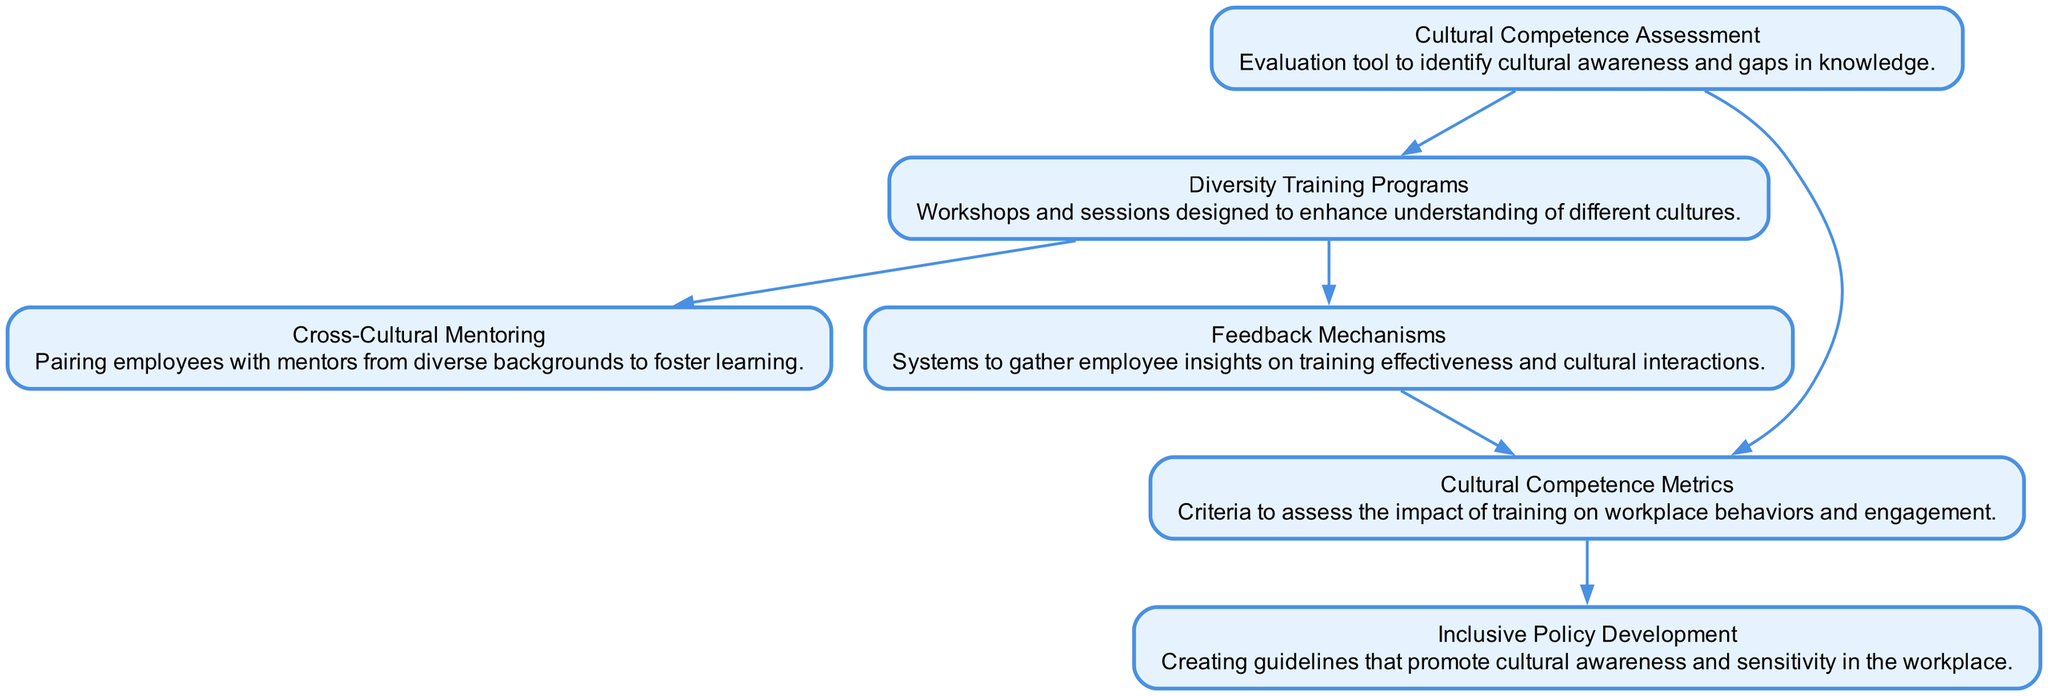What is the first node in the directed graph? The directed graph starts with the node labeled "Cultural Competence Assessment." This is identified as the initial point in the flow of the diagram, as it does not have any incoming edges.
Answer: Cultural Competence Assessment How many nodes are present in the diagram? By counting each unique element listed under "elements," we find a total of six nodes: Cultural Competence Assessment, Diversity Training Programs, Cross-Cultural Mentoring, Feedback Mechanisms, Cultural Competence Metrics, and Inclusive Policy Development.
Answer: Six Which node is directly connected to "Training Programs"? The "Mentoring" and "Feedback Mechanisms" nodes are both directly connected to the "Training Programs" node. This means both nodes receive output from "Training Programs."
Answer: Mentoring, Feedback Mechanisms What node does "Evaluation Metrics" point to? "Evaluation Metrics" points to the "Inclusive Policy Development" node, indicating that the evaluation metrics impact the development of inclusive policies in the workplace.
Answer: Inclusive Policy Development What is the relationship between "Cultural Assessment" and "Policy Development"? "Cultural Assessment" is indirectly connected to "Policy Development" through "Evaluation Metrics." There are two paths: one directly from "Cultural Assessment" to "Evaluation Metrics" and another from "Evaluation Metrics" to "Policy Development." Therefore, the relationship is indirect but significant.
Answer: Indirect via Evaluation Metrics Which node lacks outgoing edges? The "Inclusive Policy Development" node lacks outgoing edges, as it does not lead to any further nodes in the diagram. This means it serves as an endpoint for the flow of information.
Answer: Inclusive Policy Development How many edges are there in total? By counting all the directed relationships listed under "relationships," we find there are a total of five edges connecting the nodes in the diagram.
Answer: Five What does the "Feedback Mechanisms" node connect to? The "Feedback Mechanisms" node connects to "Evaluation Metrics," indicating that feedback collected impacts how cultural competence is measured in the workplace.
Answer: Evaluation Metrics What is the main purpose of "Diversity Training Programs"? The main purpose of "Diversity Training Programs" is to enhance understanding of different cultures, as described in its definition. This training is crucial for increasing cultural awareness among employees.
Answer: Enhance understanding of different cultures 